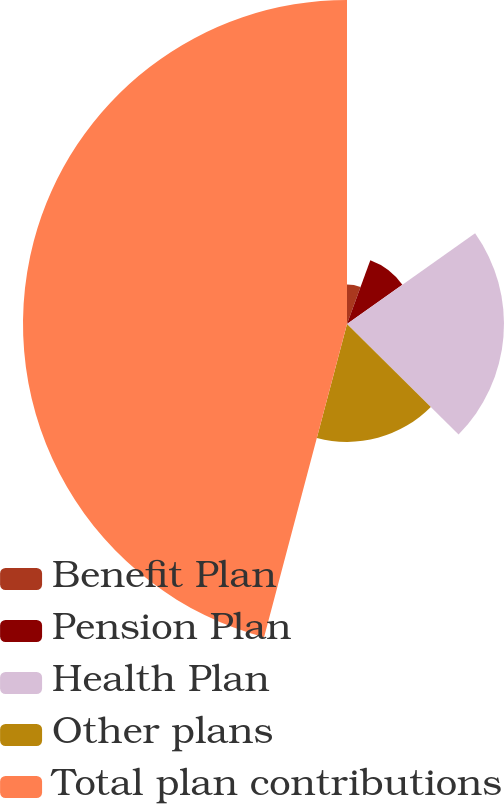Convert chart to OTSL. <chart><loc_0><loc_0><loc_500><loc_500><pie_chart><fcel>Benefit Plan<fcel>Pension Plan<fcel>Health Plan<fcel>Other plans<fcel>Total plan contributions<nl><fcel>5.58%<fcel>9.61%<fcel>22.23%<fcel>16.7%<fcel>45.88%<nl></chart> 